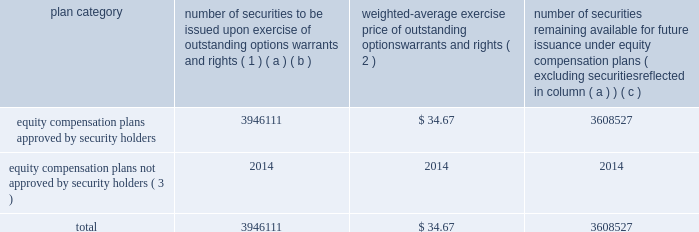Equity compensation plan information the table presents the equity securities available for issuance under our equity compensation plans as of december 31 , 2012 .
Equity compensation plan information plan category number of securities to be issued upon exercise of outstanding options , warrants and rights ( 1 ) weighted-average exercise price of outstanding options , warrants and rights ( 2 ) number of securities remaining available for future issuance under equity compensation plans ( excluding securities reflected in column ( a ) ) ( a ) ( b ) ( c ) equity compensation plans approved by security holders 3946111 $ 34.67 3608527 equity compensation plans not approved by security holders ( 3 ) 2014 2014 2014 .
( 1 ) includes grants made under the huntington ingalls industries , inc .
2012 long-term incentive stock plan ( the "2012 plan" ) , which was approved by our stockholders on may 2 , 2012 , and the huntington ingalls industries , inc .
2011 long-term incentive stock plan ( the "2011 plan" ) , which was approved by the sole stockholder of hii prior to its spin-off from northrop grumman corporation .
Of these shares , 1166492 were subject to stock options , 2060138 were subject to outstanding restricted performance stock rights , 641556 were restricted stock rights , and 63033 were stock rights granted under the 2011 plan .
In addition , this number includes 9129 stock rights and 5763 restricted performance stock rights granted under the 2012 plan , assuming target performance achievement .
( 2 ) this is the weighted average exercise price of the 1166492 outstanding stock options only .
( 3 ) there are no awards made under plans not approved by security holders .
Item 13 .
Certain relationships and related transactions , and director independence information as to certain relationships and related transactions and director independence will be incorporated herein by reference to the proxy statement for our 2013 annual meeting of stockholders to be filed within 120 days after the end of the company 2019s fiscal year .
Item 14 .
Principal accountant fees and services information as to principal accountant fees and services will be incorporated herein by reference to the proxy statement for our 2013 annual meeting of stockholders to be filed within 120 days after the end of the company 2019s fiscal year. .
What portion of the total number of securities is issued? 
Computations: (3946111 / (3946111 + 3608527))
Answer: 0.52234. Equity compensation plan information the table presents the equity securities available for issuance under our equity compensation plans as of december 31 , 2012 .
Equity compensation plan information plan category number of securities to be issued upon exercise of outstanding options , warrants and rights ( 1 ) weighted-average exercise price of outstanding options , warrants and rights ( 2 ) number of securities remaining available for future issuance under equity compensation plans ( excluding securities reflected in column ( a ) ) ( a ) ( b ) ( c ) equity compensation plans approved by security holders 3946111 $ 34.67 3608527 equity compensation plans not approved by security holders ( 3 ) 2014 2014 2014 .
( 1 ) includes grants made under the huntington ingalls industries , inc .
2012 long-term incentive stock plan ( the "2012 plan" ) , which was approved by our stockholders on may 2 , 2012 , and the huntington ingalls industries , inc .
2011 long-term incentive stock plan ( the "2011 plan" ) , which was approved by the sole stockholder of hii prior to its spin-off from northrop grumman corporation .
Of these shares , 1166492 were subject to stock options , 2060138 were subject to outstanding restricted performance stock rights , 641556 were restricted stock rights , and 63033 were stock rights granted under the 2011 plan .
In addition , this number includes 9129 stock rights and 5763 restricted performance stock rights granted under the 2012 plan , assuming target performance achievement .
( 2 ) this is the weighted average exercise price of the 1166492 outstanding stock options only .
( 3 ) there are no awards made under plans not approved by security holders .
Item 13 .
Certain relationships and related transactions , and director independence information as to certain relationships and related transactions and director independence will be incorporated herein by reference to the proxy statement for our 2013 annual meeting of stockholders to be filed within 120 days after the end of the company 2019s fiscal year .
Item 14 .
Principal accountant fees and services information as to principal accountant fees and services will be incorporated herein by reference to the proxy statement for our 2013 annual meeting of stockholders to be filed within 120 days after the end of the company 2019s fiscal year. .
What is the total value of issued securities that are approved by security holders , in billions? 
Computations: ((3946111 * 34.67) / 1000000000)
Answer: 0.13681. 